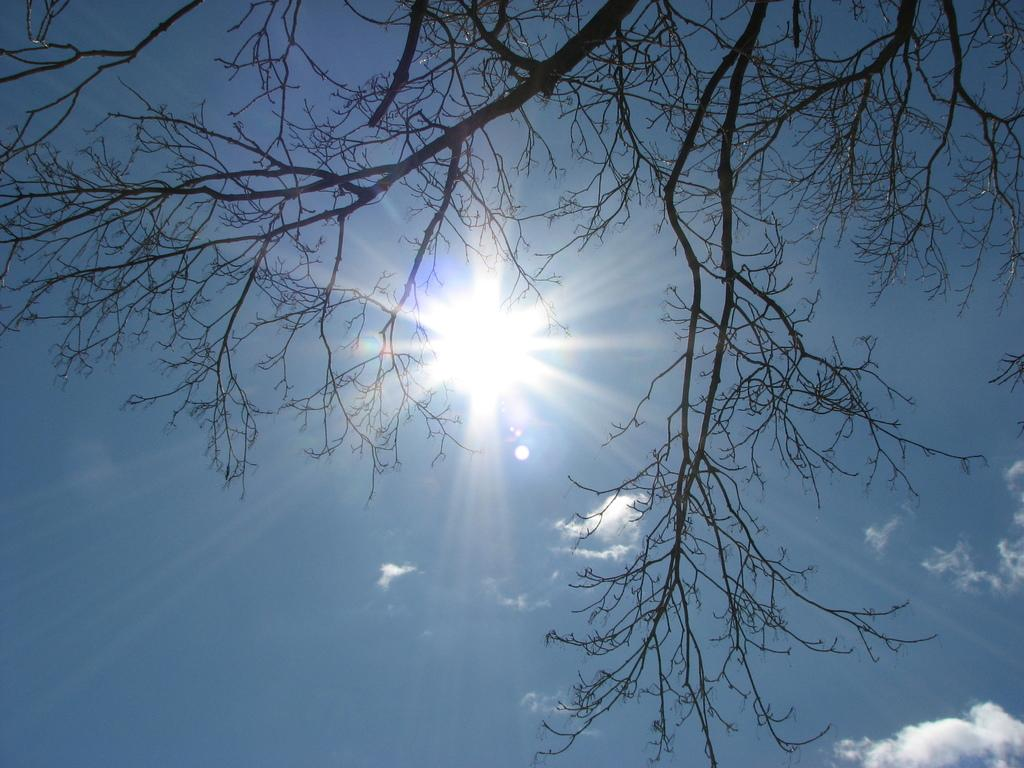What is located at the top of the image? There is a tree at the top of the image. What can be seen in the background of the image? The sky is visible in the background of the image. What celestial body is observable in the sky? The sun is observable in the sky. What else is present in the sky? Clouds are present in the sky. How many chickens are sitting on the tree in the image? There are no chickens present in the image; it features a tree and the sky. What type of hair can be seen on the brother in the image? There is no brother or any person in the image; it only shows a tree and the sky. 